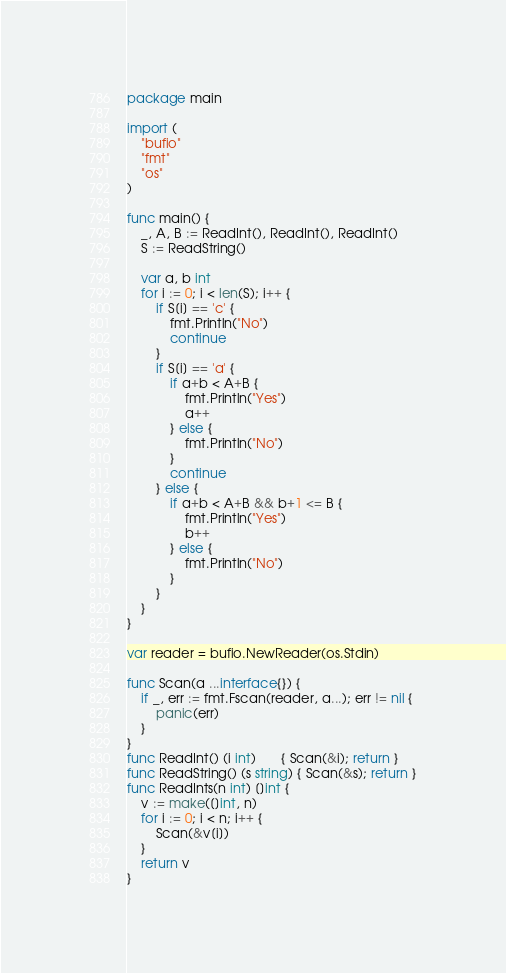Convert code to text. <code><loc_0><loc_0><loc_500><loc_500><_Go_>package main

import (
	"bufio"
	"fmt"
	"os"
)

func main() {
	_, A, B := ReadInt(), ReadInt(), ReadInt()
	S := ReadString()

	var a, b int
	for i := 0; i < len(S); i++ {
		if S[i] == 'c' {
			fmt.Println("No")
			continue
		}
		if S[i] == 'a' {
			if a+b < A+B {
				fmt.Println("Yes")
				a++
			} else {
				fmt.Println("No")
			}
			continue
		} else {
			if a+b < A+B && b+1 <= B {
				fmt.Println("Yes")
				b++
			} else {
				fmt.Println("No")
			}
		}
	}
}

var reader = bufio.NewReader(os.Stdin)

func Scan(a ...interface{}) {
	if _, err := fmt.Fscan(reader, a...); err != nil {
		panic(err)
	}
}
func ReadInt() (i int)       { Scan(&i); return }
func ReadString() (s string) { Scan(&s); return }
func ReadInts(n int) []int {
	v := make([]int, n)
	for i := 0; i < n; i++ {
		Scan(&v[i])
	}
	return v
}
</code> 